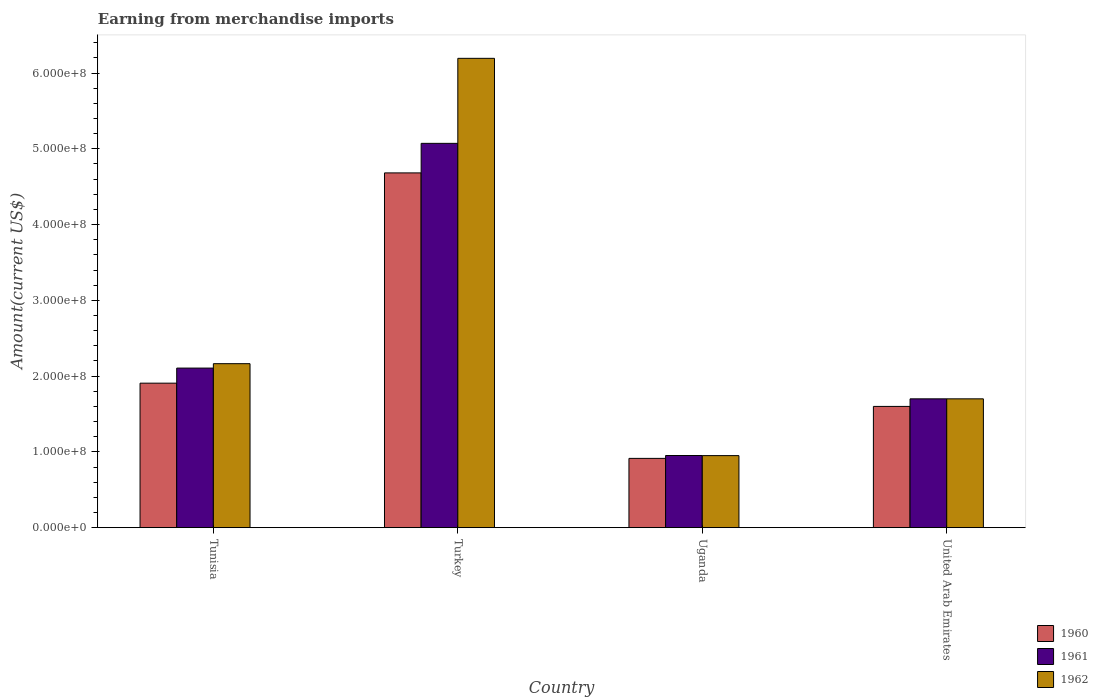How many groups of bars are there?
Make the answer very short. 4. Are the number of bars per tick equal to the number of legend labels?
Provide a short and direct response. Yes. Are the number of bars on each tick of the X-axis equal?
Give a very brief answer. Yes. How many bars are there on the 4th tick from the left?
Provide a short and direct response. 3. How many bars are there on the 1st tick from the right?
Offer a very short reply. 3. What is the label of the 1st group of bars from the left?
Make the answer very short. Tunisia. What is the amount earned from merchandise imports in 1961 in Uganda?
Offer a very short reply. 9.52e+07. Across all countries, what is the maximum amount earned from merchandise imports in 1961?
Offer a very short reply. 5.07e+08. Across all countries, what is the minimum amount earned from merchandise imports in 1962?
Offer a terse response. 9.51e+07. In which country was the amount earned from merchandise imports in 1960 maximum?
Ensure brevity in your answer.  Turkey. In which country was the amount earned from merchandise imports in 1960 minimum?
Your response must be concise. Uganda. What is the total amount earned from merchandise imports in 1962 in the graph?
Offer a very short reply. 1.10e+09. What is the difference between the amount earned from merchandise imports in 1962 in Turkey and that in United Arab Emirates?
Your response must be concise. 4.49e+08. What is the difference between the amount earned from merchandise imports in 1962 in Turkey and the amount earned from merchandise imports in 1960 in Tunisia?
Give a very brief answer. 4.29e+08. What is the average amount earned from merchandise imports in 1962 per country?
Keep it short and to the point. 2.75e+08. What is the difference between the amount earned from merchandise imports of/in 1961 and amount earned from merchandise imports of/in 1960 in Tunisia?
Your answer should be compact. 1.99e+07. What is the ratio of the amount earned from merchandise imports in 1960 in Turkey to that in Uganda?
Offer a very short reply. 5.12. Is the difference between the amount earned from merchandise imports in 1961 in Tunisia and Uganda greater than the difference between the amount earned from merchandise imports in 1960 in Tunisia and Uganda?
Make the answer very short. Yes. What is the difference between the highest and the second highest amount earned from merchandise imports in 1962?
Your response must be concise. 4.03e+08. What is the difference between the highest and the lowest amount earned from merchandise imports in 1962?
Your answer should be compact. 5.24e+08. What does the 3rd bar from the left in Turkey represents?
Offer a terse response. 1962. Is it the case that in every country, the sum of the amount earned from merchandise imports in 1960 and amount earned from merchandise imports in 1961 is greater than the amount earned from merchandise imports in 1962?
Make the answer very short. Yes. Are all the bars in the graph horizontal?
Provide a short and direct response. No. Are the values on the major ticks of Y-axis written in scientific E-notation?
Offer a terse response. Yes. Does the graph contain grids?
Your answer should be compact. No. Where does the legend appear in the graph?
Offer a terse response. Bottom right. What is the title of the graph?
Provide a short and direct response. Earning from merchandise imports. What is the label or title of the Y-axis?
Provide a short and direct response. Amount(current US$). What is the Amount(current US$) in 1960 in Tunisia?
Keep it short and to the point. 1.91e+08. What is the Amount(current US$) of 1961 in Tunisia?
Keep it short and to the point. 2.11e+08. What is the Amount(current US$) in 1962 in Tunisia?
Offer a terse response. 2.16e+08. What is the Amount(current US$) in 1960 in Turkey?
Provide a succinct answer. 4.68e+08. What is the Amount(current US$) of 1961 in Turkey?
Your response must be concise. 5.07e+08. What is the Amount(current US$) of 1962 in Turkey?
Offer a terse response. 6.19e+08. What is the Amount(current US$) in 1960 in Uganda?
Ensure brevity in your answer.  9.14e+07. What is the Amount(current US$) of 1961 in Uganda?
Keep it short and to the point. 9.52e+07. What is the Amount(current US$) of 1962 in Uganda?
Offer a very short reply. 9.51e+07. What is the Amount(current US$) in 1960 in United Arab Emirates?
Your answer should be very brief. 1.60e+08. What is the Amount(current US$) in 1961 in United Arab Emirates?
Give a very brief answer. 1.70e+08. What is the Amount(current US$) of 1962 in United Arab Emirates?
Ensure brevity in your answer.  1.70e+08. Across all countries, what is the maximum Amount(current US$) in 1960?
Offer a terse response. 4.68e+08. Across all countries, what is the maximum Amount(current US$) in 1961?
Give a very brief answer. 5.07e+08. Across all countries, what is the maximum Amount(current US$) of 1962?
Provide a succinct answer. 6.19e+08. Across all countries, what is the minimum Amount(current US$) in 1960?
Ensure brevity in your answer.  9.14e+07. Across all countries, what is the minimum Amount(current US$) of 1961?
Offer a very short reply. 9.52e+07. Across all countries, what is the minimum Amount(current US$) in 1962?
Your response must be concise. 9.51e+07. What is the total Amount(current US$) of 1960 in the graph?
Your response must be concise. 9.10e+08. What is the total Amount(current US$) in 1961 in the graph?
Offer a terse response. 9.83e+08. What is the total Amount(current US$) in 1962 in the graph?
Give a very brief answer. 1.10e+09. What is the difference between the Amount(current US$) of 1960 in Tunisia and that in Turkey?
Keep it short and to the point. -2.78e+08. What is the difference between the Amount(current US$) in 1961 in Tunisia and that in Turkey?
Keep it short and to the point. -2.97e+08. What is the difference between the Amount(current US$) in 1962 in Tunisia and that in Turkey?
Offer a very short reply. -4.03e+08. What is the difference between the Amount(current US$) in 1960 in Tunisia and that in Uganda?
Your answer should be very brief. 9.93e+07. What is the difference between the Amount(current US$) of 1961 in Tunisia and that in Uganda?
Provide a succinct answer. 1.15e+08. What is the difference between the Amount(current US$) in 1962 in Tunisia and that in Uganda?
Give a very brief answer. 1.21e+08. What is the difference between the Amount(current US$) of 1960 in Tunisia and that in United Arab Emirates?
Provide a short and direct response. 3.07e+07. What is the difference between the Amount(current US$) in 1961 in Tunisia and that in United Arab Emirates?
Ensure brevity in your answer.  4.06e+07. What is the difference between the Amount(current US$) in 1962 in Tunisia and that in United Arab Emirates?
Offer a very short reply. 4.64e+07. What is the difference between the Amount(current US$) in 1960 in Turkey and that in Uganda?
Keep it short and to the point. 3.77e+08. What is the difference between the Amount(current US$) of 1961 in Turkey and that in Uganda?
Your answer should be very brief. 4.12e+08. What is the difference between the Amount(current US$) of 1962 in Turkey and that in Uganda?
Your answer should be very brief. 5.24e+08. What is the difference between the Amount(current US$) of 1960 in Turkey and that in United Arab Emirates?
Make the answer very short. 3.08e+08. What is the difference between the Amount(current US$) of 1961 in Turkey and that in United Arab Emirates?
Make the answer very short. 3.37e+08. What is the difference between the Amount(current US$) in 1962 in Turkey and that in United Arab Emirates?
Offer a terse response. 4.49e+08. What is the difference between the Amount(current US$) of 1960 in Uganda and that in United Arab Emirates?
Provide a succinct answer. -6.86e+07. What is the difference between the Amount(current US$) of 1961 in Uganda and that in United Arab Emirates?
Your answer should be very brief. -7.48e+07. What is the difference between the Amount(current US$) in 1962 in Uganda and that in United Arab Emirates?
Your answer should be very brief. -7.49e+07. What is the difference between the Amount(current US$) in 1960 in Tunisia and the Amount(current US$) in 1961 in Turkey?
Offer a terse response. -3.17e+08. What is the difference between the Amount(current US$) in 1960 in Tunisia and the Amount(current US$) in 1962 in Turkey?
Your answer should be compact. -4.29e+08. What is the difference between the Amount(current US$) of 1961 in Tunisia and the Amount(current US$) of 1962 in Turkey?
Make the answer very short. -4.09e+08. What is the difference between the Amount(current US$) of 1960 in Tunisia and the Amount(current US$) of 1961 in Uganda?
Your response must be concise. 9.55e+07. What is the difference between the Amount(current US$) of 1960 in Tunisia and the Amount(current US$) of 1962 in Uganda?
Give a very brief answer. 9.56e+07. What is the difference between the Amount(current US$) of 1961 in Tunisia and the Amount(current US$) of 1962 in Uganda?
Provide a short and direct response. 1.16e+08. What is the difference between the Amount(current US$) in 1960 in Tunisia and the Amount(current US$) in 1961 in United Arab Emirates?
Keep it short and to the point. 2.07e+07. What is the difference between the Amount(current US$) of 1960 in Tunisia and the Amount(current US$) of 1962 in United Arab Emirates?
Provide a succinct answer. 2.07e+07. What is the difference between the Amount(current US$) in 1961 in Tunisia and the Amount(current US$) in 1962 in United Arab Emirates?
Your response must be concise. 4.06e+07. What is the difference between the Amount(current US$) of 1960 in Turkey and the Amount(current US$) of 1961 in Uganda?
Keep it short and to the point. 3.73e+08. What is the difference between the Amount(current US$) in 1960 in Turkey and the Amount(current US$) in 1962 in Uganda?
Your answer should be compact. 3.73e+08. What is the difference between the Amount(current US$) of 1961 in Turkey and the Amount(current US$) of 1962 in Uganda?
Your response must be concise. 4.12e+08. What is the difference between the Amount(current US$) of 1960 in Turkey and the Amount(current US$) of 1961 in United Arab Emirates?
Give a very brief answer. 2.98e+08. What is the difference between the Amount(current US$) in 1960 in Turkey and the Amount(current US$) in 1962 in United Arab Emirates?
Offer a very short reply. 2.98e+08. What is the difference between the Amount(current US$) in 1961 in Turkey and the Amount(current US$) in 1962 in United Arab Emirates?
Offer a very short reply. 3.37e+08. What is the difference between the Amount(current US$) in 1960 in Uganda and the Amount(current US$) in 1961 in United Arab Emirates?
Ensure brevity in your answer.  -7.86e+07. What is the difference between the Amount(current US$) of 1960 in Uganda and the Amount(current US$) of 1962 in United Arab Emirates?
Give a very brief answer. -7.86e+07. What is the difference between the Amount(current US$) in 1961 in Uganda and the Amount(current US$) in 1962 in United Arab Emirates?
Your answer should be very brief. -7.48e+07. What is the average Amount(current US$) of 1960 per country?
Your response must be concise. 2.28e+08. What is the average Amount(current US$) in 1961 per country?
Your response must be concise. 2.46e+08. What is the average Amount(current US$) in 1962 per country?
Make the answer very short. 2.75e+08. What is the difference between the Amount(current US$) in 1960 and Amount(current US$) in 1961 in Tunisia?
Your answer should be compact. -1.99e+07. What is the difference between the Amount(current US$) of 1960 and Amount(current US$) of 1962 in Tunisia?
Provide a succinct answer. -2.57e+07. What is the difference between the Amount(current US$) in 1961 and Amount(current US$) in 1962 in Tunisia?
Give a very brief answer. -5.81e+06. What is the difference between the Amount(current US$) in 1960 and Amount(current US$) in 1961 in Turkey?
Offer a very short reply. -3.90e+07. What is the difference between the Amount(current US$) of 1960 and Amount(current US$) of 1962 in Turkey?
Keep it short and to the point. -1.51e+08. What is the difference between the Amount(current US$) of 1961 and Amount(current US$) of 1962 in Turkey?
Your answer should be very brief. -1.12e+08. What is the difference between the Amount(current US$) of 1960 and Amount(current US$) of 1961 in Uganda?
Give a very brief answer. -3.78e+06. What is the difference between the Amount(current US$) of 1960 and Amount(current US$) of 1962 in Uganda?
Your answer should be compact. -3.64e+06. What is the difference between the Amount(current US$) in 1960 and Amount(current US$) in 1961 in United Arab Emirates?
Your response must be concise. -1.00e+07. What is the difference between the Amount(current US$) of 1960 and Amount(current US$) of 1962 in United Arab Emirates?
Your response must be concise. -1.00e+07. What is the ratio of the Amount(current US$) in 1960 in Tunisia to that in Turkey?
Provide a short and direct response. 0.41. What is the ratio of the Amount(current US$) in 1961 in Tunisia to that in Turkey?
Offer a very short reply. 0.42. What is the ratio of the Amount(current US$) of 1962 in Tunisia to that in Turkey?
Make the answer very short. 0.35. What is the ratio of the Amount(current US$) in 1960 in Tunisia to that in Uganda?
Ensure brevity in your answer.  2.09. What is the ratio of the Amount(current US$) of 1961 in Tunisia to that in Uganda?
Offer a very short reply. 2.21. What is the ratio of the Amount(current US$) in 1962 in Tunisia to that in Uganda?
Offer a very short reply. 2.28. What is the ratio of the Amount(current US$) in 1960 in Tunisia to that in United Arab Emirates?
Make the answer very short. 1.19. What is the ratio of the Amount(current US$) in 1961 in Tunisia to that in United Arab Emirates?
Your answer should be compact. 1.24. What is the ratio of the Amount(current US$) in 1962 in Tunisia to that in United Arab Emirates?
Provide a succinct answer. 1.27. What is the ratio of the Amount(current US$) of 1960 in Turkey to that in Uganda?
Provide a short and direct response. 5.12. What is the ratio of the Amount(current US$) of 1961 in Turkey to that in Uganda?
Provide a short and direct response. 5.33. What is the ratio of the Amount(current US$) in 1962 in Turkey to that in Uganda?
Offer a very short reply. 6.52. What is the ratio of the Amount(current US$) in 1960 in Turkey to that in United Arab Emirates?
Offer a very short reply. 2.93. What is the ratio of the Amount(current US$) in 1961 in Turkey to that in United Arab Emirates?
Your answer should be very brief. 2.98. What is the ratio of the Amount(current US$) in 1962 in Turkey to that in United Arab Emirates?
Provide a succinct answer. 3.64. What is the ratio of the Amount(current US$) of 1961 in Uganda to that in United Arab Emirates?
Offer a very short reply. 0.56. What is the ratio of the Amount(current US$) in 1962 in Uganda to that in United Arab Emirates?
Offer a very short reply. 0.56. What is the difference between the highest and the second highest Amount(current US$) in 1960?
Ensure brevity in your answer.  2.78e+08. What is the difference between the highest and the second highest Amount(current US$) of 1961?
Provide a succinct answer. 2.97e+08. What is the difference between the highest and the second highest Amount(current US$) of 1962?
Ensure brevity in your answer.  4.03e+08. What is the difference between the highest and the lowest Amount(current US$) in 1960?
Make the answer very short. 3.77e+08. What is the difference between the highest and the lowest Amount(current US$) of 1961?
Your answer should be very brief. 4.12e+08. What is the difference between the highest and the lowest Amount(current US$) of 1962?
Provide a succinct answer. 5.24e+08. 